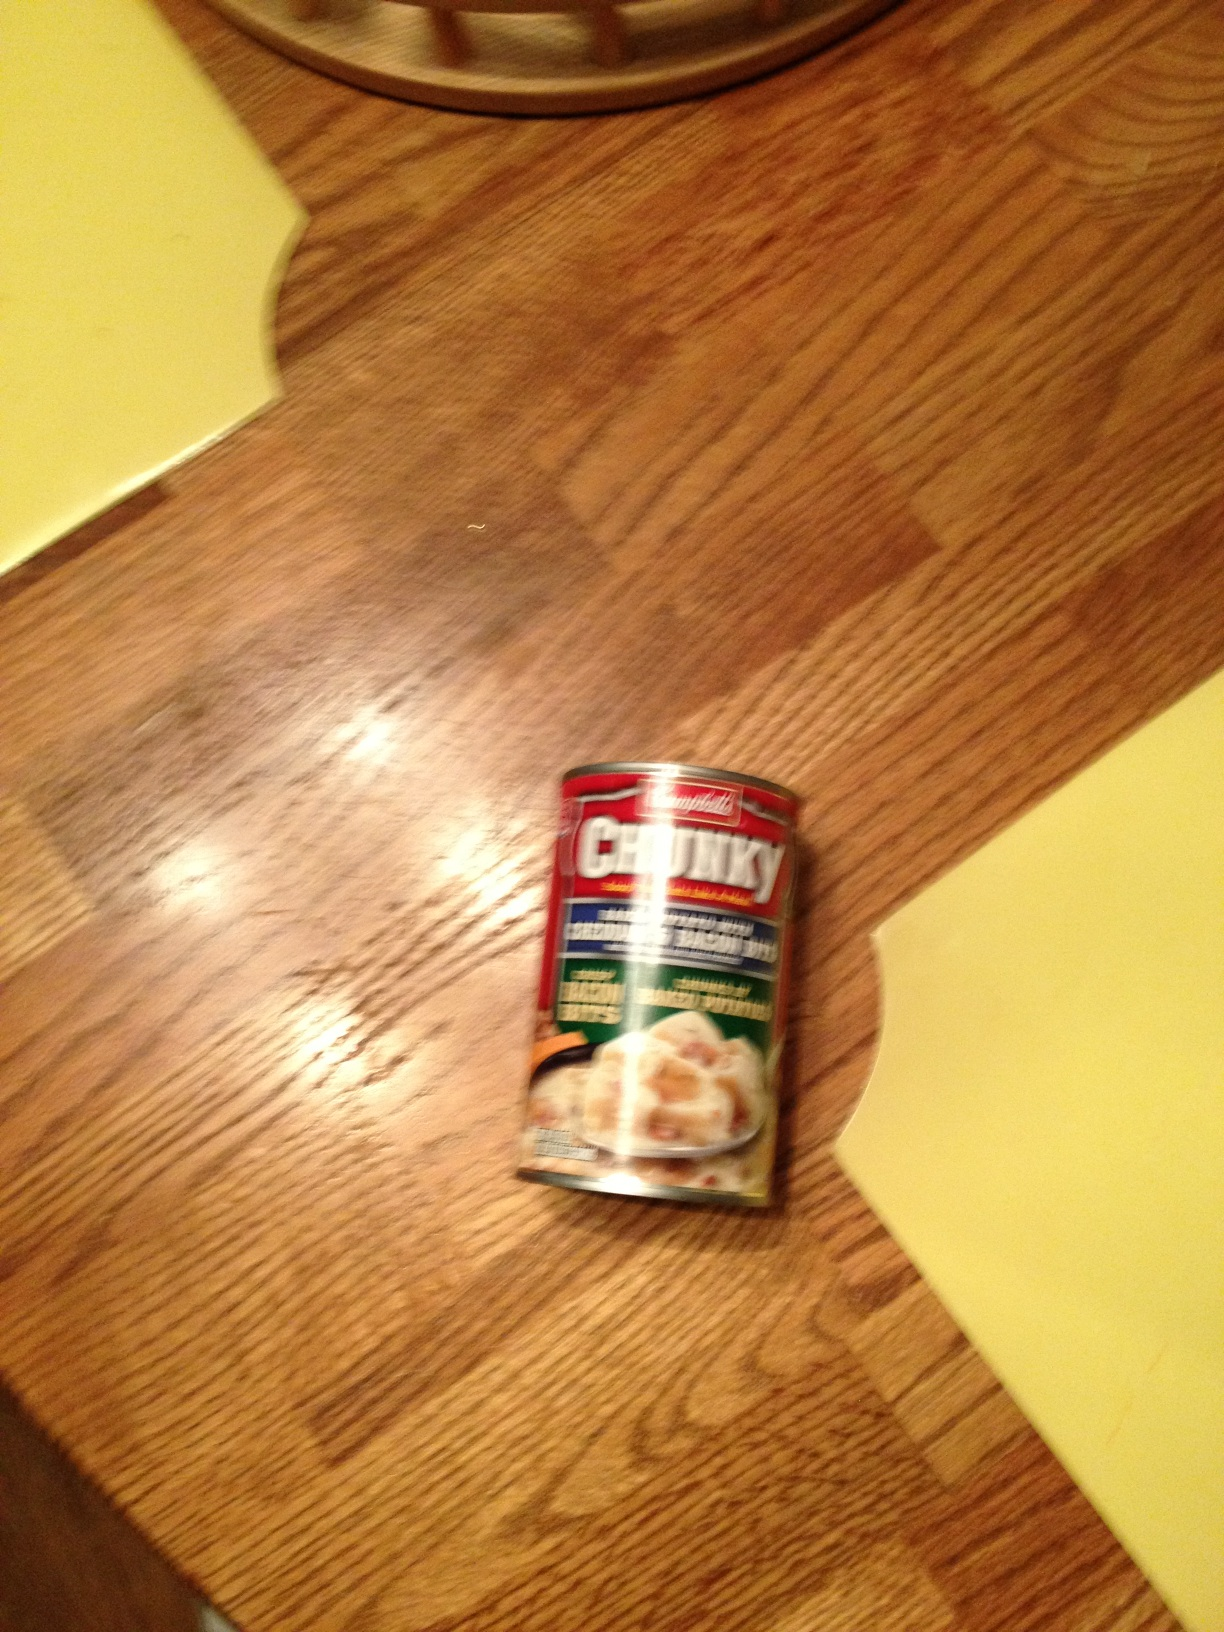Is this type of product considered healthy? Canned soups like this one can offer some nutritional benefits, such as protein from the chicken. However, they may also contain high levels of sodium and preservatives. It's always best to check the label for nutritional information to make an informed decision. 